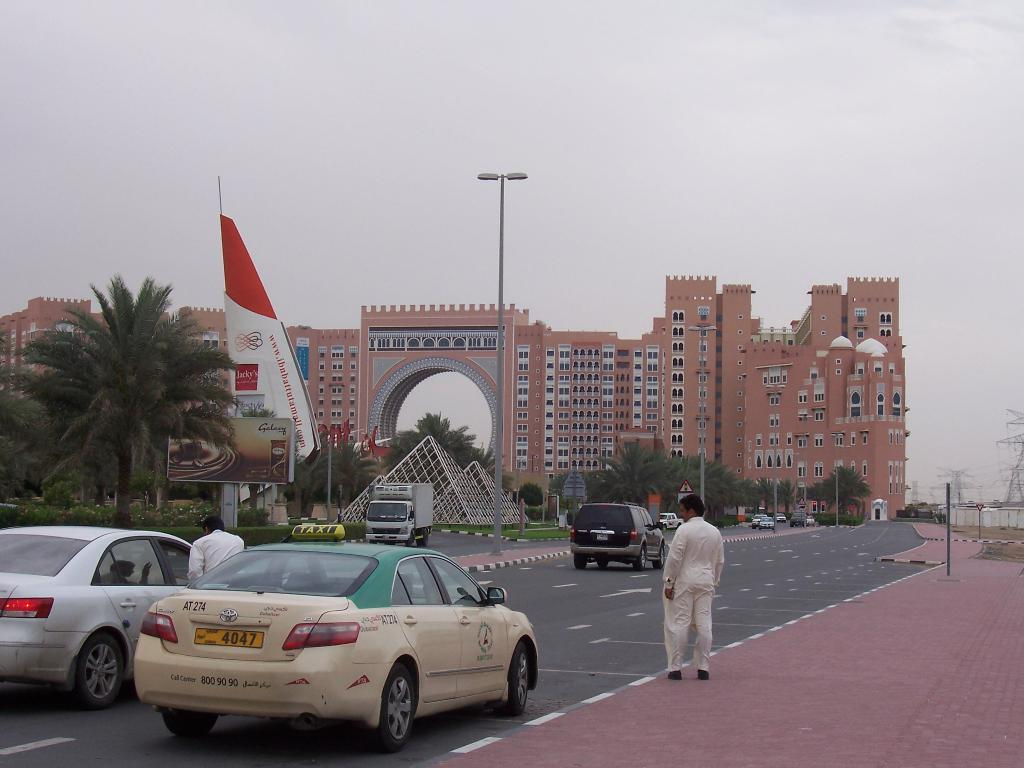<image>
Provide a brief description of the given image. A man in white coveralls stands next to a green and white car marked AT274 on the trunk/boot lid. 